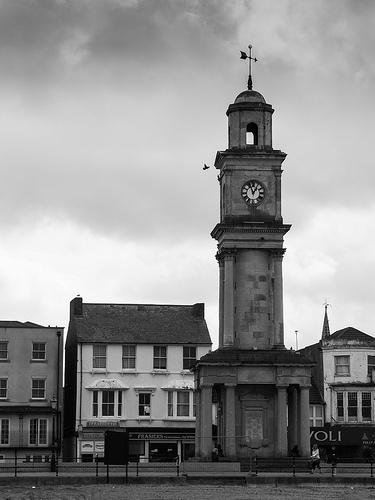Question: what is the small object flying next to the clock?
Choices:
A. Bat.
B. Drone.
C. Bee.
D. Bird.
Answer with the letter. Answer: D Question: what does the tower contain?
Choices:
A. Electronics.
B. Bell.
C. Clock.
D. Nothing.
Answer with the letter. Answer: C Question: what is walking in front of clock tower?
Choices:
A. Woman.
B. Student.
C. Man.
D. Child.
Answer with the letter. Answer: A Question: where can you find the bird in the picture?
Choices:
A. Telephone wire.
B. Ground.
C. Tree.
D. Sky.
Answer with the letter. Answer: D Question: what is in front of the clock tower?
Choices:
A. Fence.
B. Bushes.
C. Flowers.
D. Tree.
Answer with the letter. Answer: A 